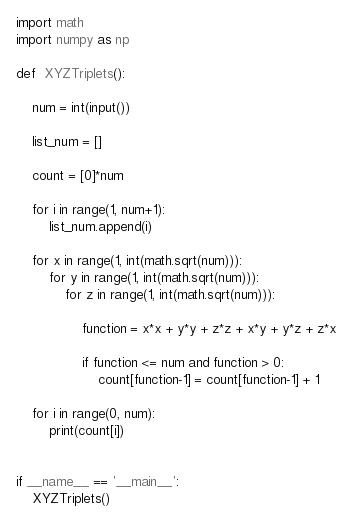<code> <loc_0><loc_0><loc_500><loc_500><_Python_>import math
import numpy as np

def  XYZTriplets():

    num = int(input())
    
    list_num = []
    
    count = [0]*num
    
    for i in range(1, num+1):
        list_num.append(i)

    for x in range(1, int(math.sqrt(num))):
        for y in range(1, int(math.sqrt(num))):
            for z in range(1, int(math.sqrt(num))):
                
                function = x*x + y*y + z*z + x*y + y*z + z*x
                
                if function <= num and function > 0:
                    count[function-1] = count[function-1] + 1
 
    for i in range(0, num):
        print(count[i])
        

if __name__ == '__main__':
    XYZTriplets()
</code> 